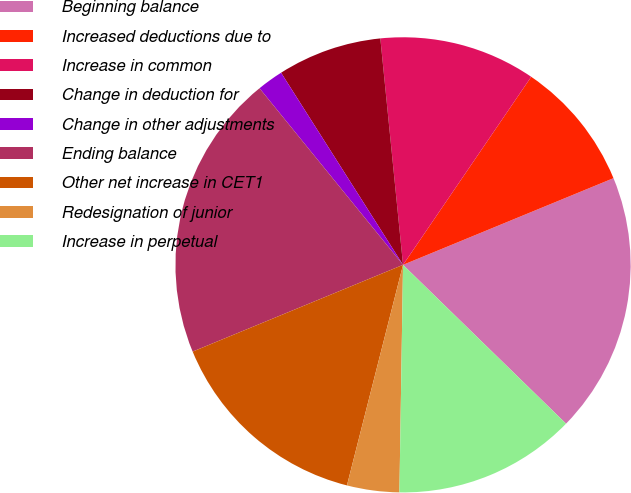Convert chart. <chart><loc_0><loc_0><loc_500><loc_500><pie_chart><fcel>Beginning balance<fcel>Increased deductions due to<fcel>Increase in common<fcel>Change in deduction for<fcel>Change in other adjustments<fcel>Ending balance<fcel>Other net increase in CET1<fcel>Redesignation of junior<fcel>Increase in perpetual<nl><fcel>18.51%<fcel>9.26%<fcel>11.11%<fcel>7.41%<fcel>1.86%<fcel>20.36%<fcel>14.81%<fcel>3.71%<fcel>12.96%<nl></chart> 